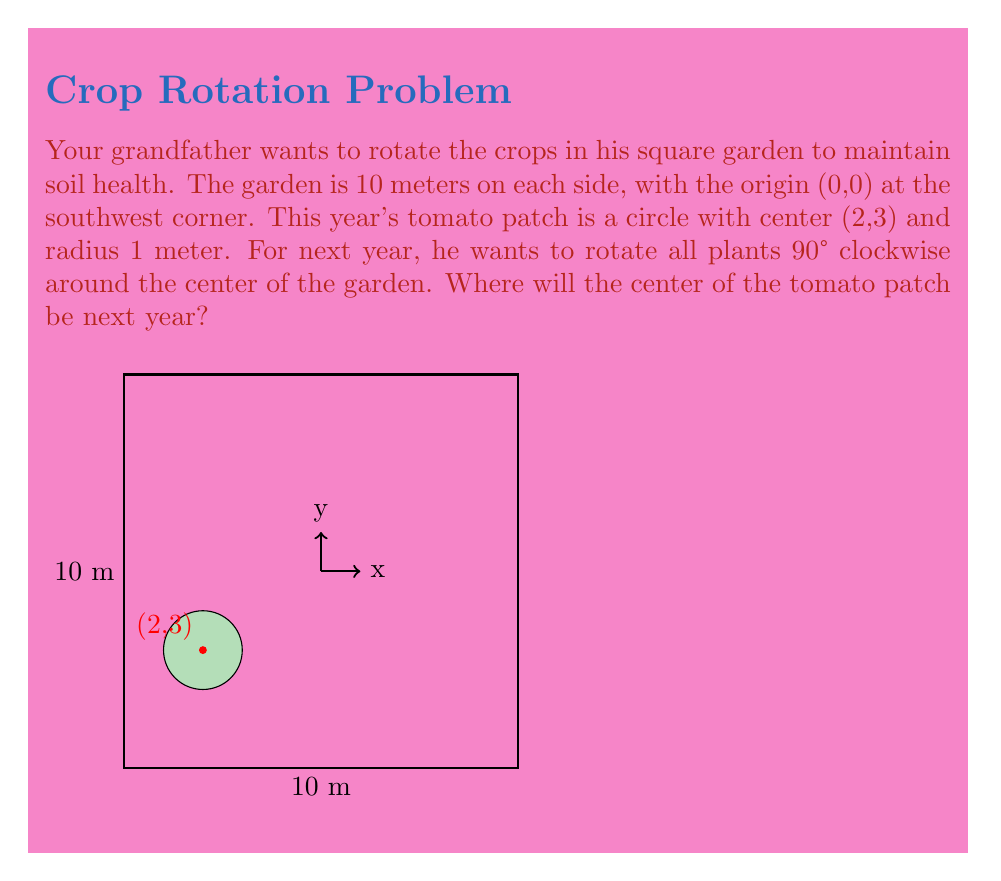Show me your answer to this math problem. Let's approach this step-by-step:

1) First, we need to identify the center of the garden. Since it's a 10x10 meter square with the origin at (0,0), the center is at (5,5).

2) To rotate a point 90° clockwise around the origin, we use the transformation:
   $$(x,y) \rightarrow (y,-x)$$

3) However, we're rotating around (5,5), not (0,0). So we need to:
   a) Translate the point so (5,5) becomes the origin
   b) Apply the rotation
   c) Translate back

4) Let's call our original point $(x,y) = (2,3)$

5) Translating to make (5,5) the origin:
   $$(x-5, y-5) = (2-5, 3-5) = (-3,-2)$$

6) Applying the 90° clockwise rotation:
   $$(-3,-2) \rightarrow (-2,3)$$

7) Translating back:
   $$(-2+5, 3+5) = (3,8)$$

Therefore, the center of the tomato patch will be at (3,8) next year.
Answer: (3,8) 